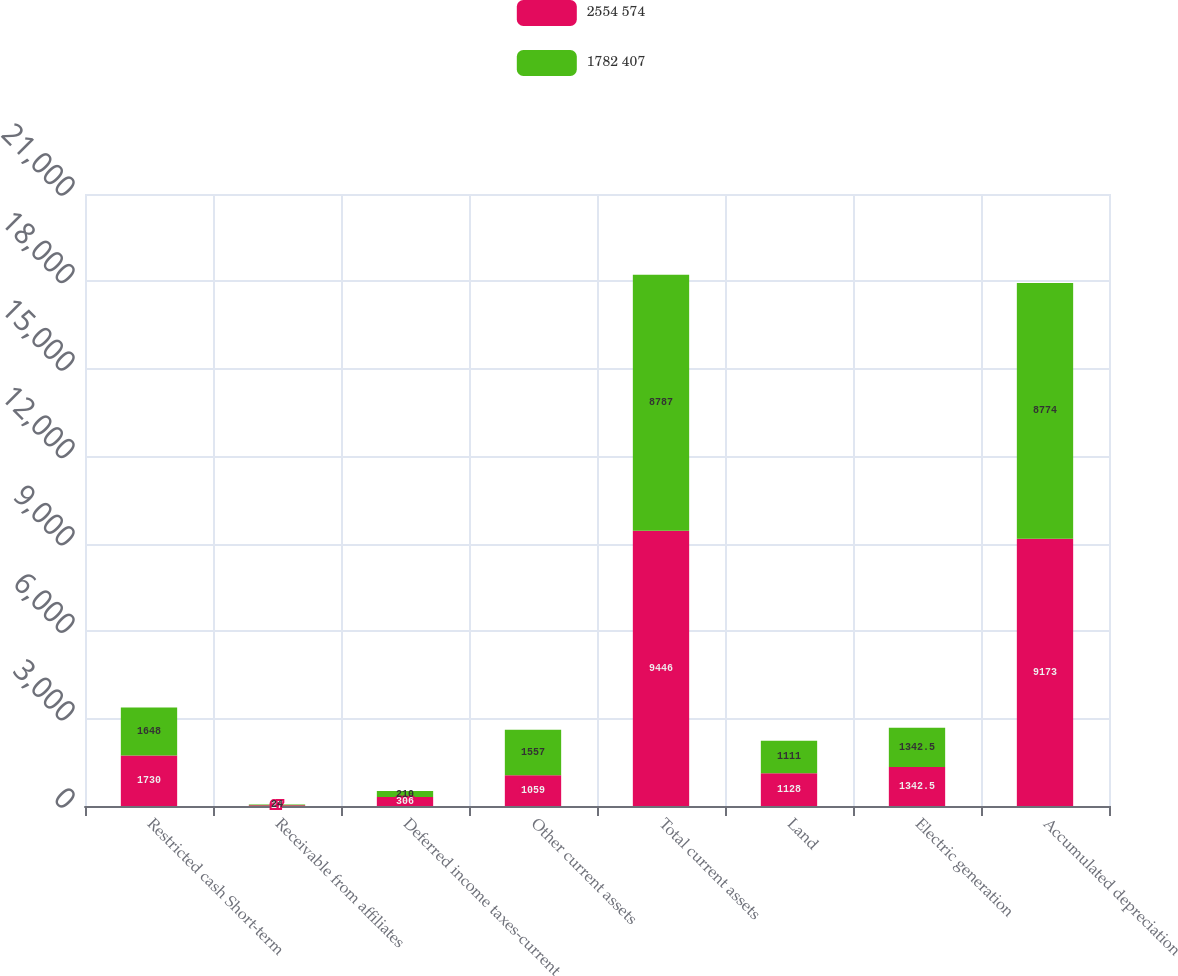<chart> <loc_0><loc_0><loc_500><loc_500><stacked_bar_chart><ecel><fcel>Restricted cash Short-term<fcel>Receivable from affiliates<fcel>Deferred income taxes-current<fcel>Other current assets<fcel>Total current assets<fcel>Land<fcel>Electric generation<fcel>Accumulated depreciation<nl><fcel>2554 574<fcel>1730<fcel>27<fcel>306<fcel>1059<fcel>9446<fcel>1128<fcel>1342.5<fcel>9173<nl><fcel>1782 407<fcel>1648<fcel>24<fcel>210<fcel>1557<fcel>8787<fcel>1111<fcel>1342.5<fcel>8774<nl></chart> 